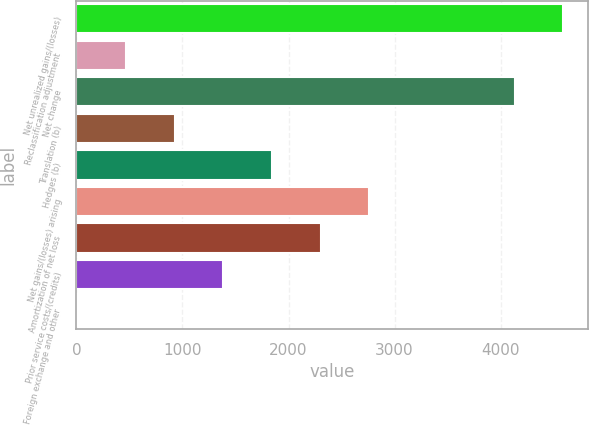Convert chart to OTSL. <chart><loc_0><loc_0><loc_500><loc_500><bar_chart><fcel>Net unrealized gains/(losses)<fcel>Reclassification adjustment<fcel>Net change<fcel>Translation (b)<fcel>Hedges (b)<fcel>Net gains/(losses) arising<fcel>Amortization of net loss<fcel>Prior service costs/(credits)<fcel>Foreign exchange and other<nl><fcel>4591<fcel>470.8<fcel>4133.2<fcel>928.6<fcel>1844.2<fcel>2759.8<fcel>2302<fcel>1386.4<fcel>13<nl></chart> 